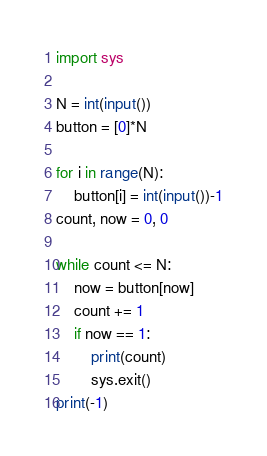Convert code to text. <code><loc_0><loc_0><loc_500><loc_500><_Python_>import sys

N = int(input())
button = [0]*N

for i in range(N):
    button[i] = int(input())-1
count, now = 0, 0

while count <= N:
    now = button[now]
    count += 1
    if now == 1:
        print(count)
        sys.exit()
print(-1)
</code> 